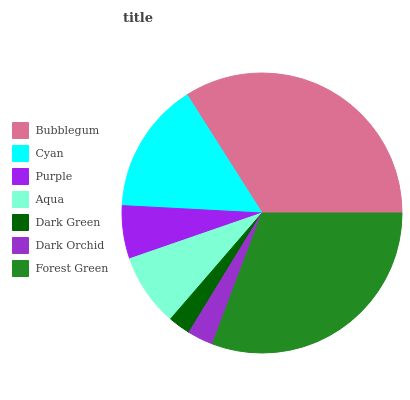Is Dark Green the minimum?
Answer yes or no. Yes. Is Bubblegum the maximum?
Answer yes or no. Yes. Is Cyan the minimum?
Answer yes or no. No. Is Cyan the maximum?
Answer yes or no. No. Is Bubblegum greater than Cyan?
Answer yes or no. Yes. Is Cyan less than Bubblegum?
Answer yes or no. Yes. Is Cyan greater than Bubblegum?
Answer yes or no. No. Is Bubblegum less than Cyan?
Answer yes or no. No. Is Aqua the high median?
Answer yes or no. Yes. Is Aqua the low median?
Answer yes or no. Yes. Is Cyan the high median?
Answer yes or no. No. Is Forest Green the low median?
Answer yes or no. No. 